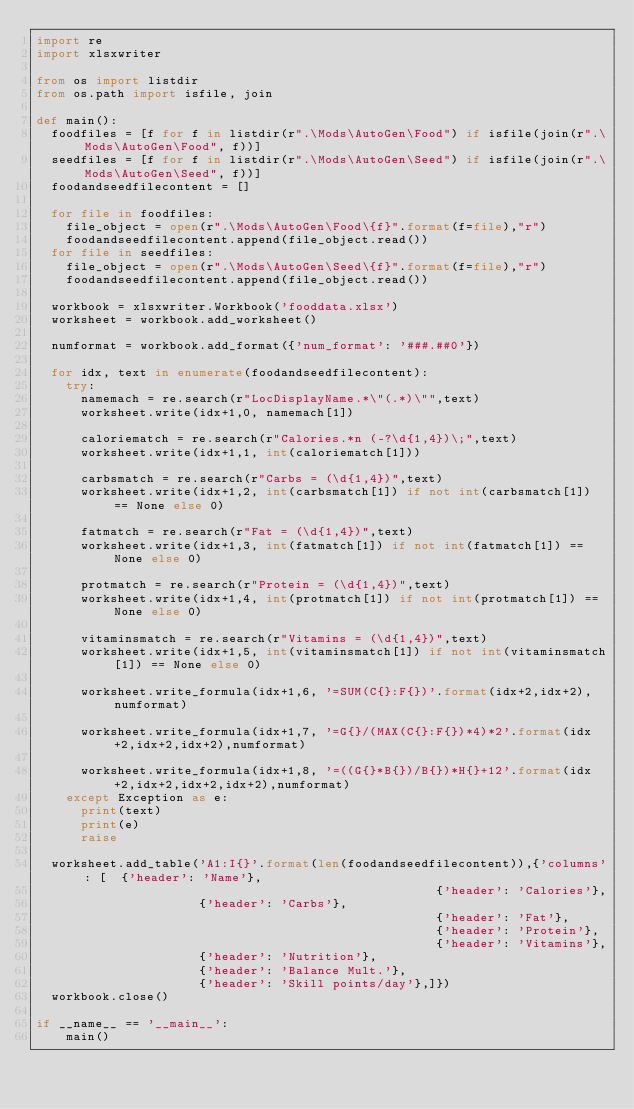<code> <loc_0><loc_0><loc_500><loc_500><_Python_>import re
import xlsxwriter

from os import listdir
from os.path import isfile, join

def main():
	foodfiles = [f for f in listdir(r".\Mods\AutoGen\Food") if isfile(join(r".\Mods\AutoGen\Food", f))]
	seedfiles = [f for f in listdir(r".\Mods\AutoGen\Seed") if isfile(join(r".\Mods\AutoGen\Seed", f))]
	foodandseedfilecontent = []

	for file in foodfiles:
		file_object = open(r".\Mods\AutoGen\Food\{f}".format(f=file),"r")
		foodandseedfilecontent.append(file_object.read())
	for file in seedfiles:
		file_object = open(r".\Mods\AutoGen\Seed\{f}".format(f=file),"r")
		foodandseedfilecontent.append(file_object.read())

	workbook = xlsxwriter.Workbook('fooddata.xlsx')
	worksheet = workbook.add_worksheet()

	numformat = workbook.add_format({'num_format': '###.##0'})

	for idx, text in enumerate(foodandseedfilecontent):
		try:
			namemach = re.search(r"LocDisplayName.*\"(.*)\"",text)
			worksheet.write(idx+1,0, namemach[1])

			caloriematch = re.search(r"Calories.*n (-?\d{1,4})\;",text)
			worksheet.write(idx+1,1, int(caloriematch[1]))

			carbsmatch = re.search(r"Carbs = (\d{1,4})",text)
			worksheet.write(idx+1,2, int(carbsmatch[1]) if not int(carbsmatch[1]) == None else 0)

			fatmatch = re.search(r"Fat = (\d{1,4})",text)
			worksheet.write(idx+1,3, int(fatmatch[1]) if not int(fatmatch[1]) == None else 0)

			protmatch = re.search(r"Protein = (\d{1,4})",text)
			worksheet.write(idx+1,4, int(protmatch[1]) if not int(protmatch[1]) == None else 0)

			vitaminsmatch = re.search(r"Vitamins = (\d{1,4})",text)
			worksheet.write(idx+1,5, int(vitaminsmatch[1]) if not int(vitaminsmatch[1]) == None else 0)

			worksheet.write_formula(idx+1,6, '=SUM(C{}:F{})'.format(idx+2,idx+2),numformat)

			worksheet.write_formula(idx+1,7, '=G{}/(MAX(C{}:F{})*4)*2'.format(idx+2,idx+2,idx+2),numformat)

			worksheet.write_formula(idx+1,8, '=((G{}*B{})/B{})*H{}+12'.format(idx+2,idx+2,idx+2,idx+2),numformat)
		except Exception as e:
			print(text)
			print(e)
			raise

	worksheet.add_table('A1:I{}'.format(len(foodandseedfilecontent)),{'columns': [  {'header': 'Name'},
                                          						{'header': 'Calories'},
											{'header': 'Carbs'},
                                          						{'header': 'Fat'},
                                          						{'header': 'Protein'},
                                          						{'header': 'Vitamins'},
											{'header': 'Nutrition'},
											{'header': 'Balance Mult.'},
											{'header': 'Skill points/day'},]})
	workbook.close()

if __name__ == '__main__':
    main()
</code> 